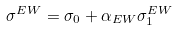<formula> <loc_0><loc_0><loc_500><loc_500>\sigma ^ { E W } = \sigma _ { 0 } + \alpha _ { E W } \sigma _ { 1 } ^ { E W }</formula> 